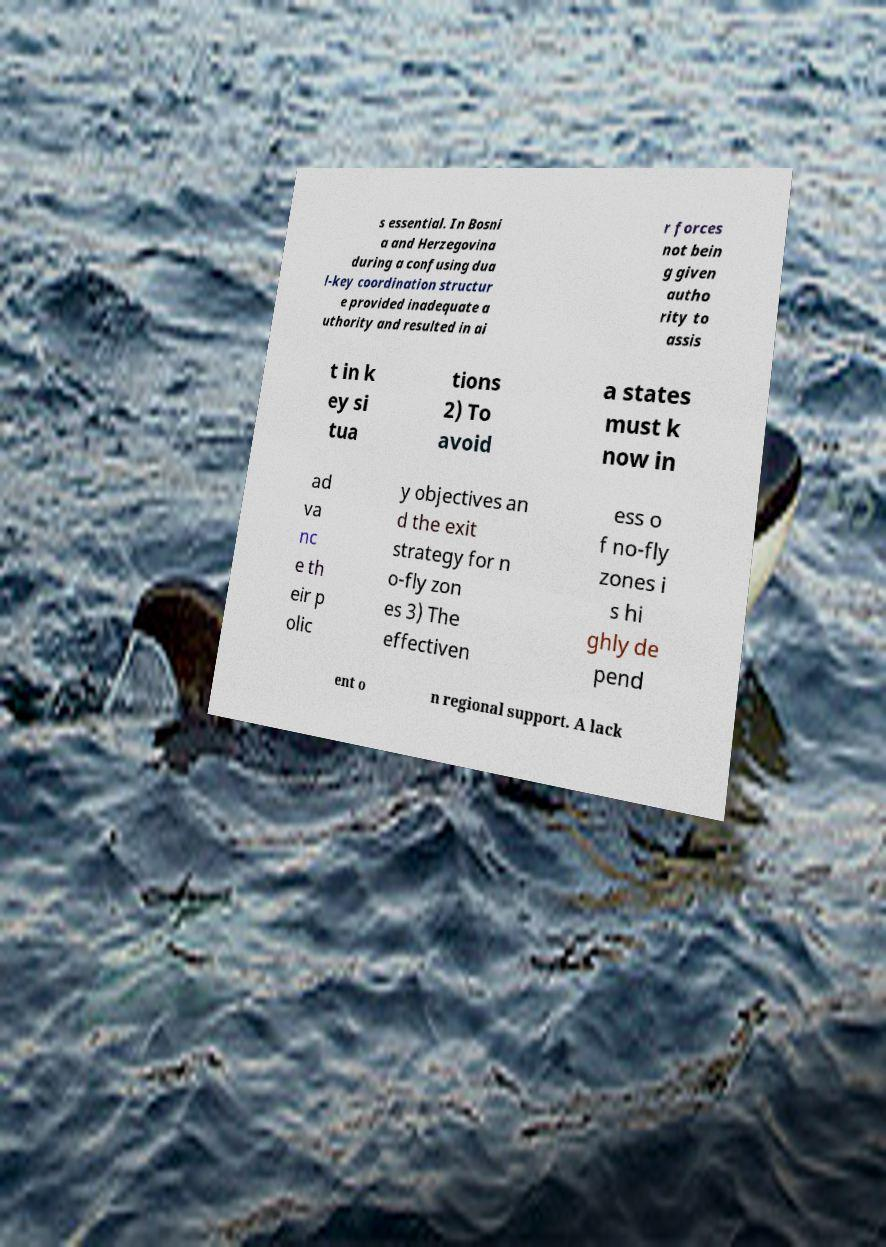What messages or text are displayed in this image? I need them in a readable, typed format. s essential. In Bosni a and Herzegovina during a confusing dua l-key coordination structur e provided inadequate a uthority and resulted in ai r forces not bein g given autho rity to assis t in k ey si tua tions 2) To avoid a states must k now in ad va nc e th eir p olic y objectives an d the exit strategy for n o-fly zon es 3) The effectiven ess o f no-fly zones i s hi ghly de pend ent o n regional support. A lack 